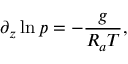<formula> <loc_0><loc_0><loc_500><loc_500>\partial _ { z } \ln p = - \frac { g } { R _ { a } T } ,</formula> 